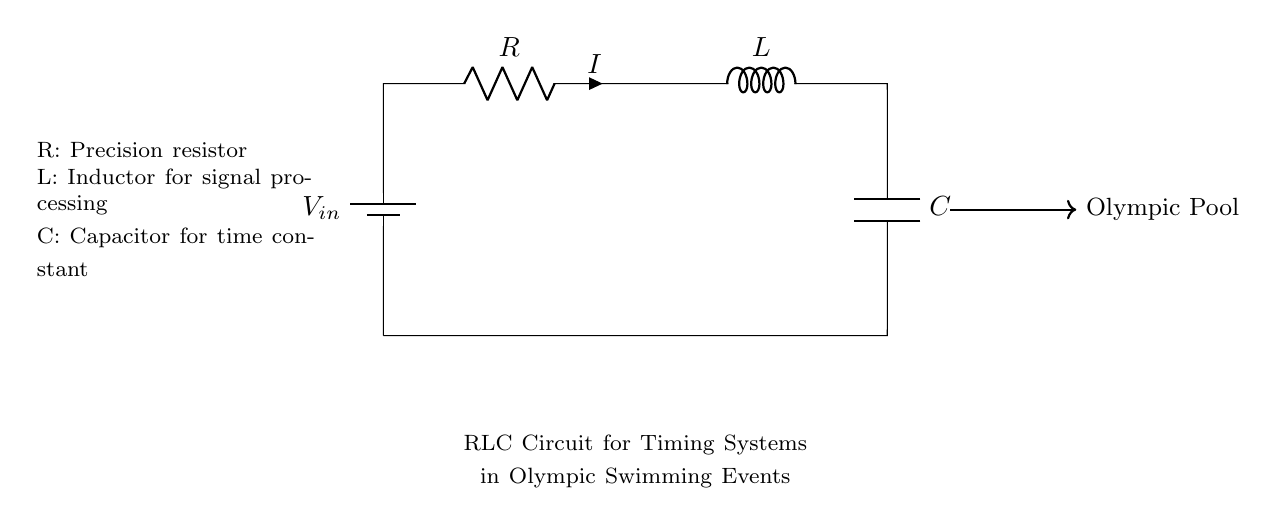What are the components in this circuit? The circuit contains a resistor, an inductor, and a capacitor, which are the basic components identifiable in the diagram.
Answer: resistor, inductor, capacitor What does the 'R' stand for in this circuit? 'R' represents a precision resistor, specifically used in timing systems for accuracy.
Answer: precision resistor What is the role of the inductor 'L' in this circuit? The inductor is used for signal processing, helping to manage the timing and response of the circuit signals.
Answer: signal processing What is the voltage source labeled as in the diagram? The voltage source is labeled as 'Vin', which stands for the input voltage provided to the circuit.
Answer: Vin How does the capacitor 'C' influence the timing in the circuit? The capacitor contributes to the time constant of the circuit, which affects how quickly the circuit can respond or charge/discharge.
Answer: time constant What is the current flowing through the circuit denoted as? The current flowing through the circuit is denoted by 'I', representing the flow of charge.
Answer: I Explain the function of the entire RLC circuit in the context of the Olympic swimming events. This RLC circuit is designed for timing systems, ensuring accurate time measurements during swimming events by managing how signals are processed and timed through the interaction of resistance, inductance, and capacitance.
Answer: timing systems 